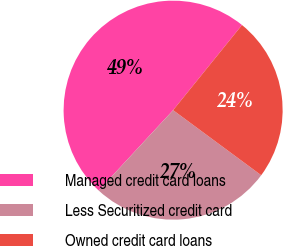Convert chart to OTSL. <chart><loc_0><loc_0><loc_500><loc_500><pie_chart><fcel>Managed credit card loans<fcel>Less Securitized credit card<fcel>Owned credit card loans<nl><fcel>48.93%<fcel>26.77%<fcel>24.3%<nl></chart> 